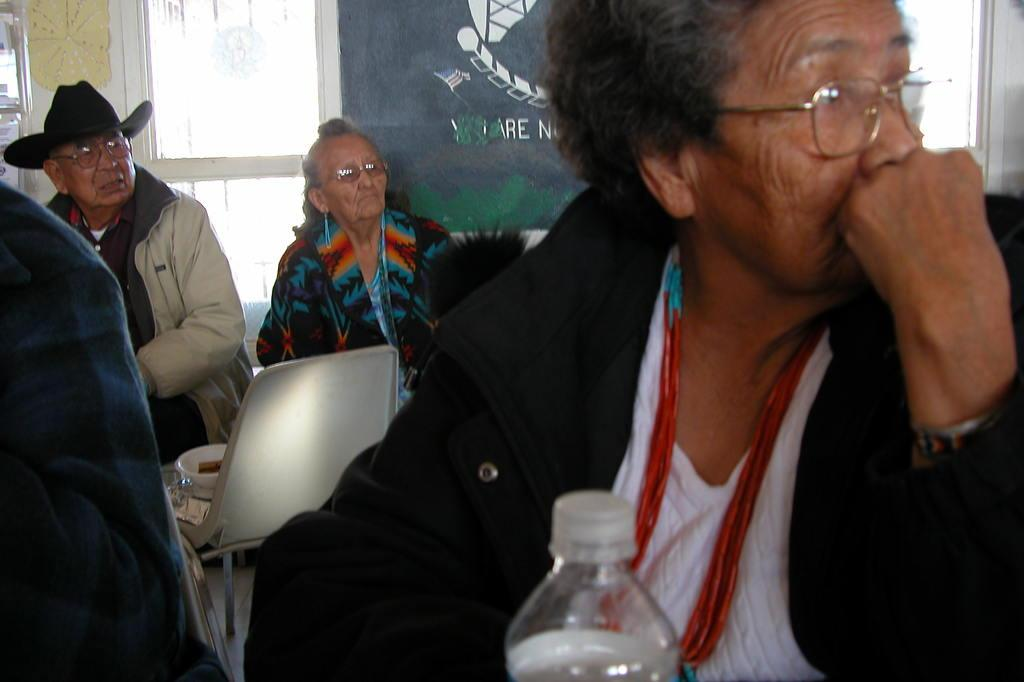What is the main subject of the image? The main subject of the image is a group of people. What are the people in the image doing? The people in the image are seated on chairs. How many beads are being used to help drain the water in the image? There is no reference to beads, water, or draining in the image; it simply shows a group of people seated on chairs. 